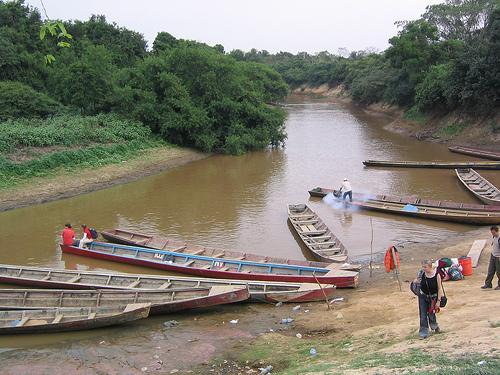Identify the types and colors of boats present in the image. There are long grey wooden boats and red and white canoes, as well as boats with blue frames present in the image. Describe the state of the water and the sky in the image. The water is brown and murky, while the sky is grey and cloudy. What are the predominant colors of clothing worn by people in the image? People in the image are predominantly wearing red, black, and white clothing. Point out a notable piece of clothing and where it is located. There is a bright orange puffy jacket hanging on a wooden post by the riverbank. Describe an interaction between a person and a boat in the image. A man wearing red is on a boat in the river, and a girl is sitting in a different boat. Mention the most noticeable person in the image and their attire. A blonde woman wearing a black tank top and blue pants is standing near the canoes. Highlight any distinct flora present in the image. There is a green tree encroaching into the water and bright green leaves nearby. What is the main activity happening near the water? There are people interacting with boats and canoes near the murky water. Mention any objects found on the ground near the riverbank. There are bottles and trash littering the ground near the riverbank. Describe the landscape and environment around the river. The riverbank is surrounded by green trees and shrubs on both sides, with brown dirt on the hillside and bottles strewn on the shore. 